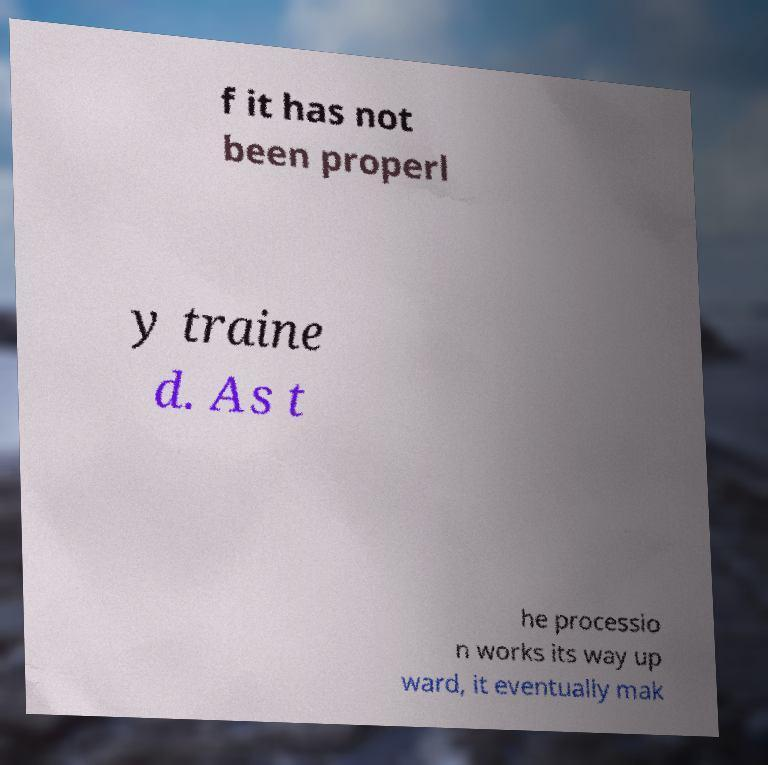Please read and relay the text visible in this image. What does it say? f it has not been properl y traine d. As t he processio n works its way up ward, it eventually mak 